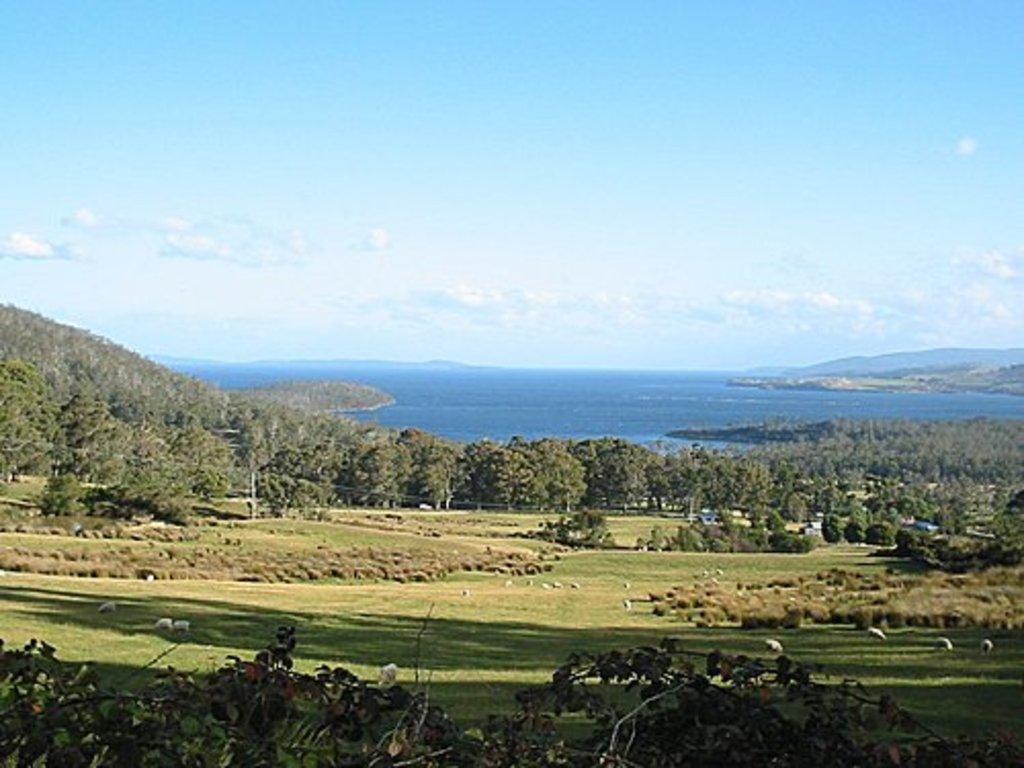What type of natural environment is depicted in the image? The image features many trees and water, suggesting a forest or woodland setting. What is located in the middle of the image? There is water in the middle of the image. What can be seen in the background of the image? The sky is visible in the background of the image. What is the condition of the sky in the image? Clouds are present in the sky. What type of decision is being made by the yam in the image? There is no yam present in the image, so no decision can be made by a yam. 